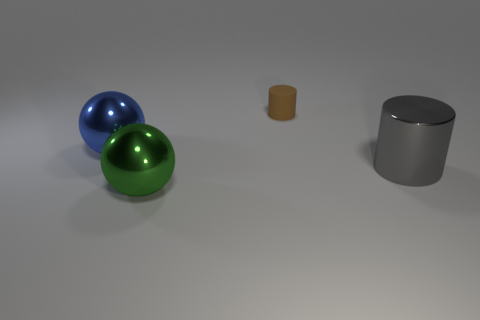The large ball behind the big green ball is what color?
Your answer should be compact. Blue. Are there any brown rubber things to the left of the ball that is behind the big green shiny thing?
Ensure brevity in your answer.  No. There is a metal object in front of the large cylinder; does it have the same color as the object behind the blue ball?
Provide a succinct answer. No. There is a blue ball; what number of matte cylinders are in front of it?
Provide a succinct answer. 0. How many large shiny objects have the same color as the tiny cylinder?
Offer a terse response. 0. Is the number of green metallic objects the same as the number of large metallic balls?
Ensure brevity in your answer.  No. Are the thing left of the green shiny thing and the tiny thing made of the same material?
Give a very brief answer. No. What number of big blue balls are the same material as the small brown cylinder?
Offer a very short reply. 0. Are there more rubber cylinders that are in front of the gray shiny object than green things?
Ensure brevity in your answer.  No. Is there a gray shiny thing that has the same shape as the large green thing?
Your answer should be compact. No. 